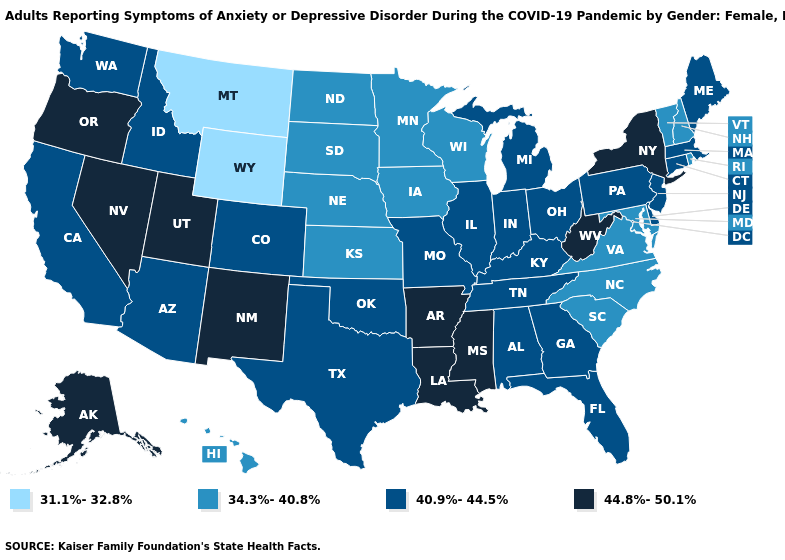Is the legend a continuous bar?
Short answer required. No. What is the value of Alabama?
Write a very short answer. 40.9%-44.5%. What is the value of South Carolina?
Answer briefly. 34.3%-40.8%. Name the states that have a value in the range 44.8%-50.1%?
Keep it brief. Alaska, Arkansas, Louisiana, Mississippi, Nevada, New Mexico, New York, Oregon, Utah, West Virginia. What is the lowest value in the Northeast?
Quick response, please. 34.3%-40.8%. Which states have the highest value in the USA?
Quick response, please. Alaska, Arkansas, Louisiana, Mississippi, Nevada, New Mexico, New York, Oregon, Utah, West Virginia. Among the states that border Wyoming , which have the highest value?
Be succinct. Utah. Does Kansas have a lower value than Idaho?
Concise answer only. Yes. How many symbols are there in the legend?
Answer briefly. 4. Which states have the lowest value in the South?
Write a very short answer. Maryland, North Carolina, South Carolina, Virginia. Among the states that border Wisconsin , does Illinois have the lowest value?
Answer briefly. No. What is the value of New York?
Answer briefly. 44.8%-50.1%. What is the value of South Carolina?
Quick response, please. 34.3%-40.8%. Name the states that have a value in the range 44.8%-50.1%?
Be succinct. Alaska, Arkansas, Louisiana, Mississippi, Nevada, New Mexico, New York, Oregon, Utah, West Virginia. 